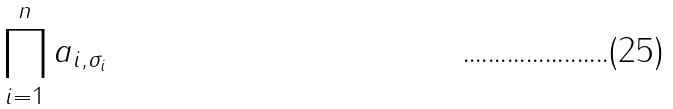<formula> <loc_0><loc_0><loc_500><loc_500>\prod _ { i = 1 } ^ { n } a _ { i , \sigma _ { i } }</formula> 